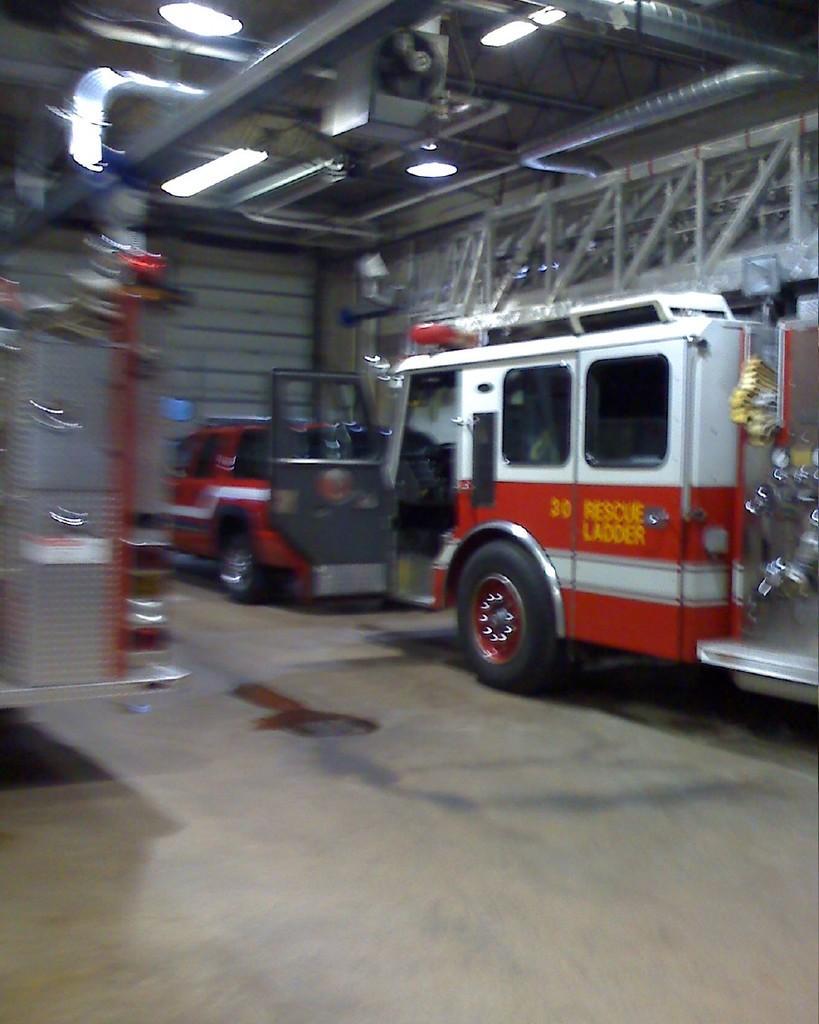In one or two sentences, can you explain what this image depicts? In the center of the image we can see vehicles are present. At the top of the image we can see roof, lights are there. At the bottom of the image a floor is there. 